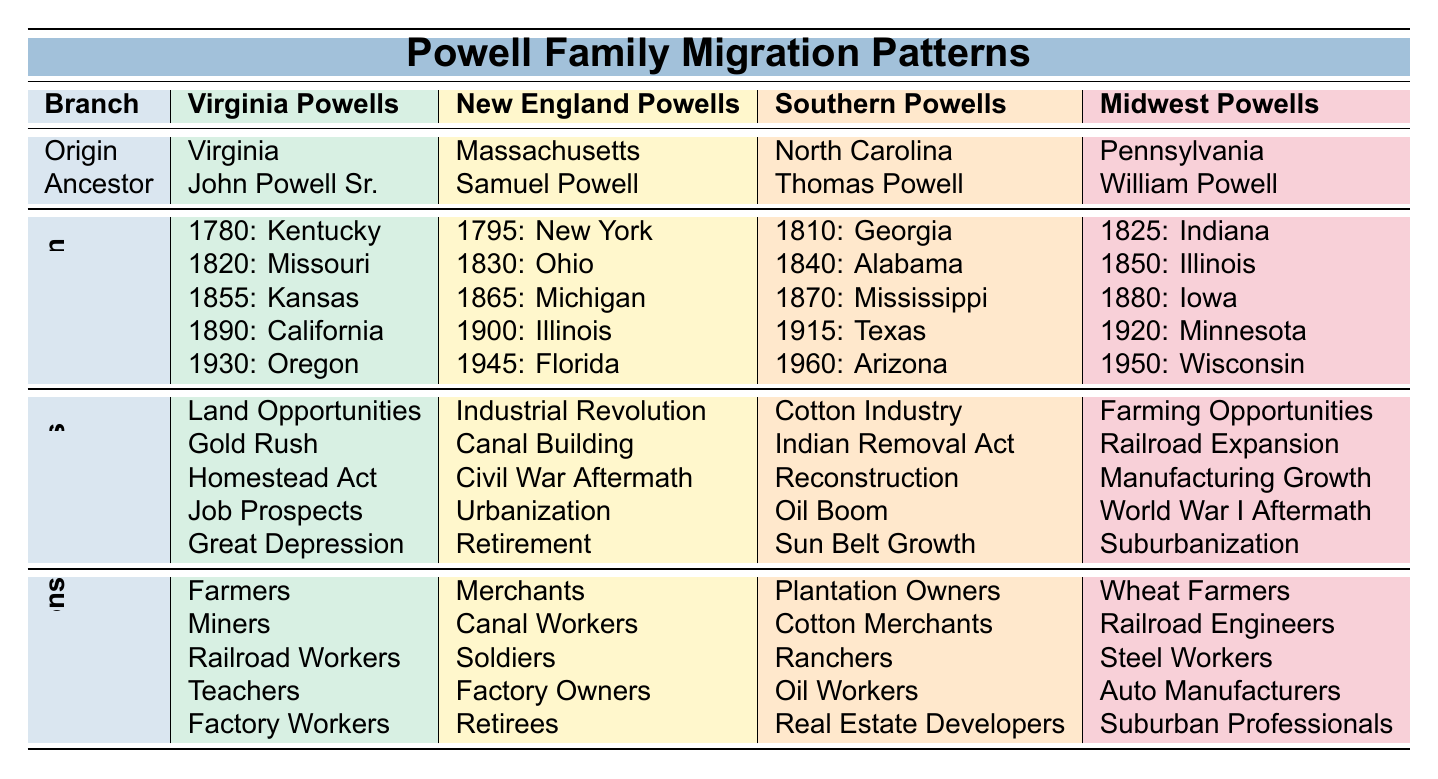What is the origin state of the Southern Powells? The table shows that the Southern Powells originate from North Carolina.
Answer: North Carolina Which migration year is associated with the New England Powells moving to Florida? From the table, the New England Powells migrated to Florida in 1945.
Answer: 1945 What is the earliest known ancestor of the Virginia Powells? According to the table, the earliest known ancestor of the Virginia Powells is John Powell Sr.
Answer: John Powell Sr How many migration years are listed for the Midwest Powells? The Midwest Powells have five migration years listed (1825, 1850, 1880, 1920, 1950), which can be counted from the table.
Answer: 5 Did the Western Powells migrate due to the Gold Rush? The table indicates that the reasons for migration for the Western Powells include Manifest Destiny, Mining Boom, Logging Industry, Great Depression, and Oil Discovery, but not the Gold Rush.
Answer: No What is the average number of reasons for migration across all branches? The table lists 5 reasons for migration for each of the 5 branches, totaling 25 reasons. To find the average, divide by the number of branches (25/5 = 5).
Answer: 5 Which branch of the Powells migrated primarily for job prospects and what were their destination states? Examining the table reveals that the Virginia Powells migrated primarily for job prospects, and their destination states were Kentucky, Missouri, Kansas, California, and Oregon.
Answer: Virginia Powells; Kentucky, Missouri, Kansas, California, Oregon What occupation is associated with the earliest known ancestor of the Midwest Powells? William Powell, the earliest known ancestor of the Midwest Powells, is associated with the occupation of Wheat Farmers as shown in the table.
Answer: Wheat Farmers What are the notable occupations listed for the Southern Powells? The notable occupations for the Southern Powells, as per the table, include Plantation Owners, Cotton Merchants, Ranchers, Oil Workers, and Real Estate Developers.
Answer: Plantation Owners, Cotton Merchants, Ranchers, Oil Workers, Real Estate Developers Which migration reason is common to both the Virginia and Southern Powells’ migration patterns? The table reveals that the migration reasons of Land Opportunities and Cotton Industry are not common; however, "Opportunities" is a theme in both, but the specific reasons do not match in the data provided.
Answer: No common migration reason 